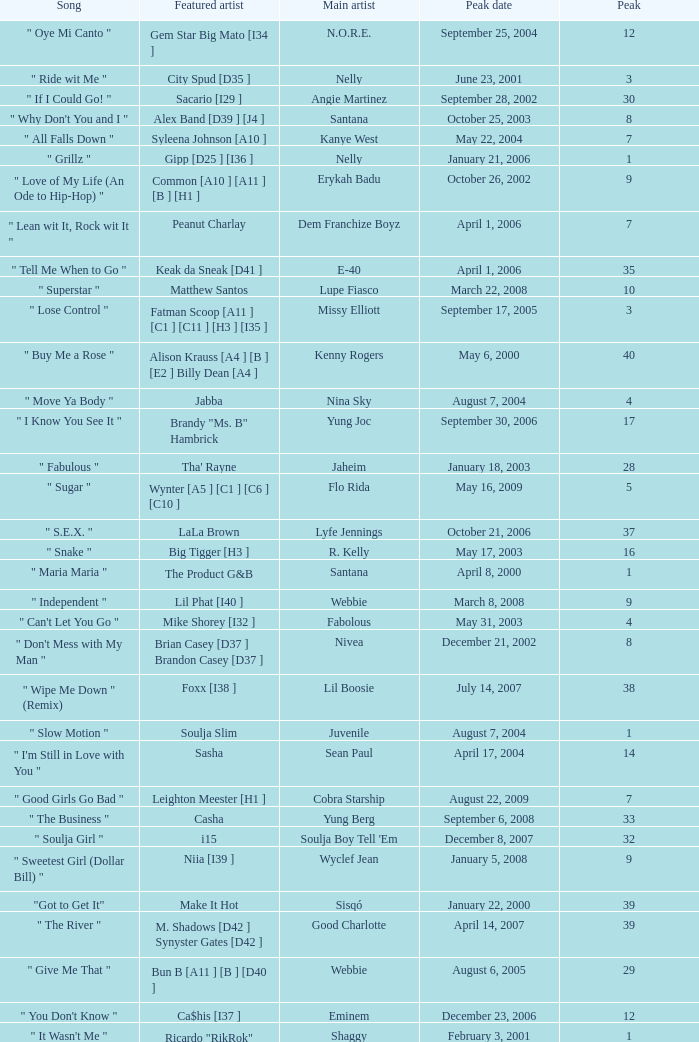Can you give me this table as a dict? {'header': ['Song', 'Featured artist', 'Main artist', 'Peak date', 'Peak'], 'rows': [['" Oye Mi Canto "', 'Gem Star Big Mato [I34 ]', 'N.O.R.E.', 'September 25, 2004', '12'], ['" Ride wit Me "', 'City Spud [D35 ]', 'Nelly', 'June 23, 2001', '3'], ['" If I Could Go! "', 'Sacario [I29 ]', 'Angie Martinez', 'September 28, 2002', '30'], ['" Why Don\'t You and I "', 'Alex Band [D39 ] [J4 ]', 'Santana', 'October 25, 2003', '8'], ['" All Falls Down "', 'Syleena Johnson [A10 ]', 'Kanye West', 'May 22, 2004', '7'], ['" Grillz "', 'Gipp [D25 ] [I36 ]', 'Nelly', 'January 21, 2006', '1'], ['" Love of My Life (An Ode to Hip-Hop) "', 'Common [A10 ] [A11 ] [B ] [H1 ]', 'Erykah Badu', 'October 26, 2002', '9'], ['" Lean wit It, Rock wit It "', 'Peanut Charlay', 'Dem Franchize Boyz', 'April 1, 2006', '7'], ['" Tell Me When to Go "', 'Keak da Sneak [D41 ]', 'E-40', 'April 1, 2006', '35'], ['" Superstar "', 'Matthew Santos', 'Lupe Fiasco', 'March 22, 2008', '10'], ['" Lose Control "', 'Fatman Scoop [A11 ] [C1 ] [C11 ] [H3 ] [I35 ]', 'Missy Elliott', 'September 17, 2005', '3'], ['" Buy Me a Rose "', 'Alison Krauss [A4 ] [B ] [E2 ] Billy Dean [A4 ]', 'Kenny Rogers', 'May 6, 2000', '40'], ['" Move Ya Body "', 'Jabba', 'Nina Sky', 'August 7, 2004', '4'], ['" I Know You See It "', 'Brandy "Ms. B" Hambrick', 'Yung Joc', 'September 30, 2006', '17'], ['" Fabulous "', "Tha' Rayne", 'Jaheim', 'January 18, 2003', '28'], ['" Sugar "', 'Wynter [A5 ] [C1 ] [C6 ] [C10 ]', 'Flo Rida', 'May 16, 2009', '5'], ['" S.E.X. "', 'LaLa Brown', 'Lyfe Jennings', 'October 21, 2006', '37'], ['" Snake "', 'Big Tigger [H3 ]', 'R. Kelly', 'May 17, 2003', '16'], ['" Maria Maria "', 'The Product G&B', 'Santana', 'April 8, 2000', '1'], ['" Independent "', 'Lil Phat [I40 ]', 'Webbie', 'March 8, 2008', '9'], ['" Can\'t Let You Go "', 'Mike Shorey [I32 ]', 'Fabolous', 'May 31, 2003', '4'], ['" Don\'t Mess with My Man "', 'Brian Casey [D37 ] Brandon Casey [D37 ]', 'Nivea', 'December 21, 2002', '8'], ['" Wipe Me Down " (Remix)', 'Foxx [I38 ]', 'Lil Boosie', 'July 14, 2007', '38'], ['" Slow Motion "', 'Soulja Slim', 'Juvenile', 'August 7, 2004', '1'], ['" I\'m Still in Love with You "', 'Sasha', 'Sean Paul', 'April 17, 2004', '14'], ['" Good Girls Go Bad "', 'Leighton Meester [H1 ]', 'Cobra Starship', 'August 22, 2009', '7'], ['" The Business "', 'Casha', 'Yung Berg', 'September 6, 2008', '33'], ['" Soulja Girl "', 'i15', "Soulja Boy Tell 'Em", 'December 8, 2007', '32'], ['" Sweetest Girl (Dollar Bill) "', 'Niia [I39 ]', 'Wyclef Jean', 'January 5, 2008', '9'], ['"Got to Get It"', 'Make It Hot', 'Sisqó', 'January 22, 2000', '39'], ['" The River "', 'M. Shadows [D42 ] Synyster Gates [D42 ]', 'Good Charlotte', 'April 14, 2007', '39'], ['" Give Me That "', 'Bun B [A11 ] [B ] [D40 ]', 'Webbie', 'August 6, 2005', '29'], ['" You Don\'t Know "', 'Ca$his [I37 ]', 'Eminem', 'December 23, 2006', '12'], ['" It Wasn\'t Me "', 'Ricardo "RikRok" Ducent', 'Shaggy', 'February 3, 2001', '1'], ['" Bad Boy for Life "', 'Black Rob [A10 ] [A11 ] Mark Curry', 'P. Diddy', 'September 8, 2001', '33'], ['" Dude "', 'Ms. Thing [I33 ]', 'Beenie Man', 'June 12, 2004', '26'], ['" Hero "', 'Josey Scott [D36 ]', 'Chad Kroeger', 'July 13, 2002', '3'], ['" Desert Rose "', 'Cheb Mami', 'Sting', 'August 26, 2000', '17'], ['" One Call Away "', 'J. Weav [H1 ]', 'Chingy', 'March 13, 2004', '2'], ['" Put It on Ya "', 'Chris J', 'Plies', 'January 3, 2009', '31'], ['" Errtime "', 'Jung Tru King Jacob', 'Nelly', 'June 4, 2005', '24'], ['" The Whole World "', 'Joi [I28 ]', 'Outkast', 'February 23, 2002', '19'], ['" Sunshine "', 'Lea', "Lil' Flip", 'October 23, 2004', '2'], ['" Move Bitch "', 'Infamous 2.0 [I30 ]', 'Ludacris', 'October 5, 2002', '10'], ['" Bossy "', 'Too $hort [A10 ] [A11 ] [A12 ] [B ]', 'Kelis', 'August 6, 2006', '16'], ['" Beautiful "', 'Charlie Wilson [A10 ] [B ] [D38 ] [I31 ]', 'Snoop Dogg', 'April 26, 2003', '6'], ['" I Know What You Want "', 'Flipmode Squad', 'Busta Rhymes and Mariah Carey', 'May 31, 2003', '3'], ['" Picture "', 'Allison Moorer [J2 ]', 'Kid Rock', 'May 10, 2003', '4'], ['" Lolli Lolli (Pop That Body) "', 'Project Pat [D44 ] Young D Superpower', 'Three 6 Mafia', 'June 14, 2008', '18'], ['" Two Wrongs', 'Claudette Ortiz [D45 ]', 'Wyclef Jean', 'August 31, 2002', '28'], ['" Big Pimpin\' "', 'UGK [A10 ] [A11 ] [B ]', 'Jay-Z', 'May 20, 2000', '18'], ['" Lollipop "', 'Static Major [D43 ] [G1 ]', 'Lil Wayne', 'May 3, 2008', '1'], ['" Hey Baby "', 'Bounty Killer', 'No Doubt', 'March 2, 2002', '6']]} What was the peak date of Kelis's song? August 6, 2006. 